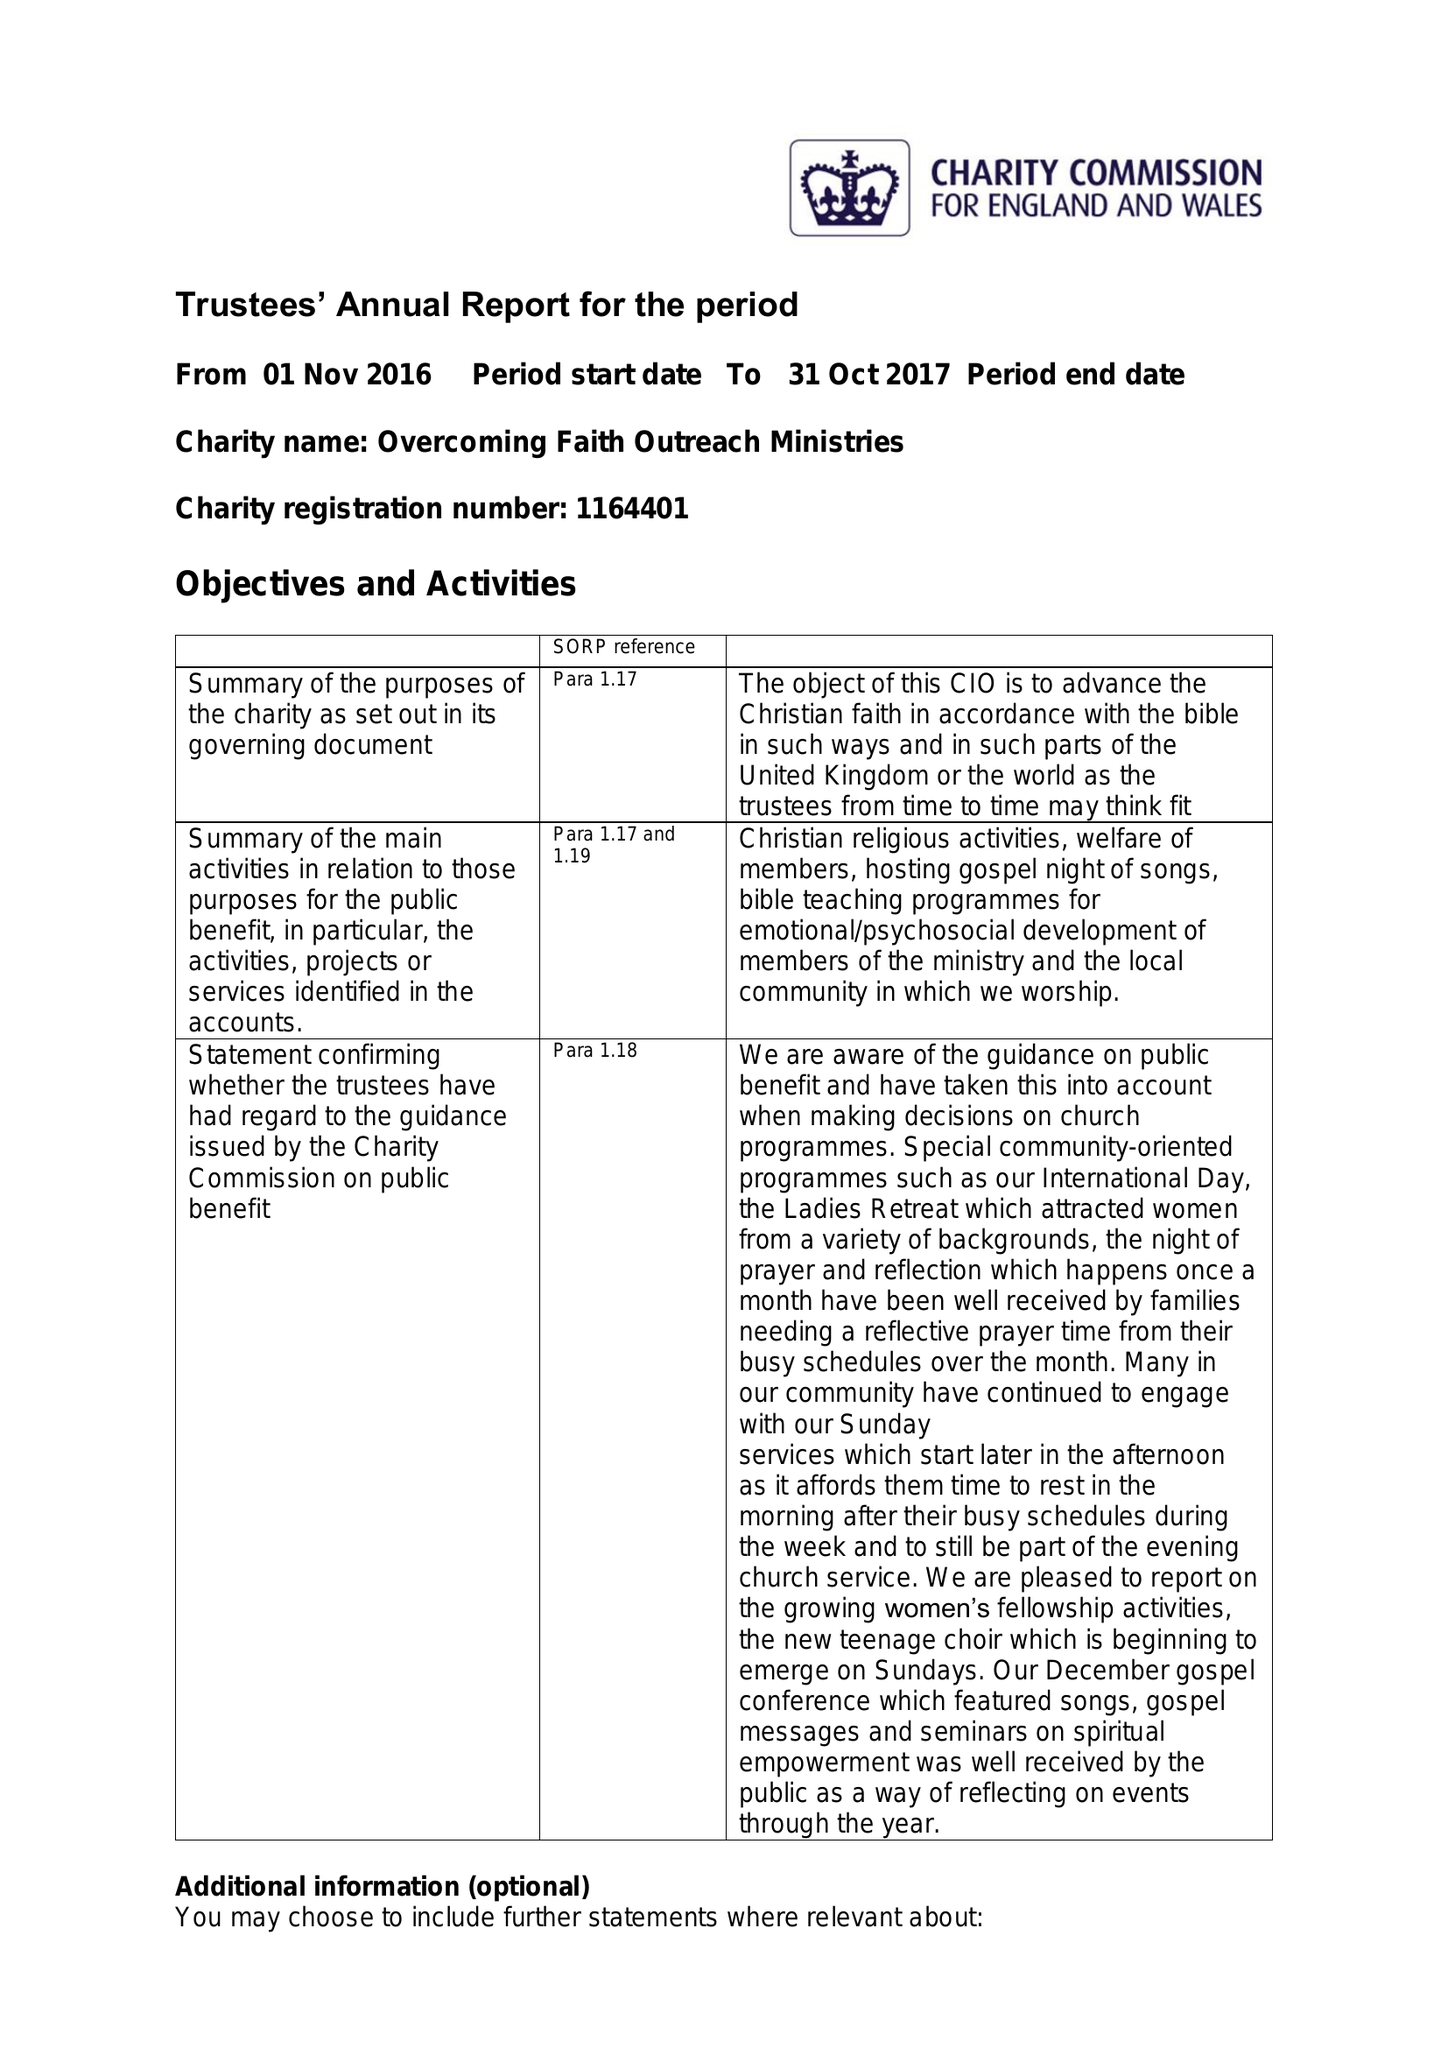What is the value for the charity_name?
Answer the question using a single word or phrase. Overcoming Faith Outreach Ministries International 